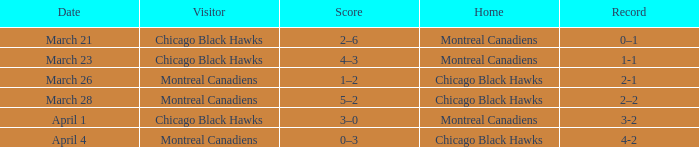Which home team has a record of 3-2? Montreal Canadiens. 